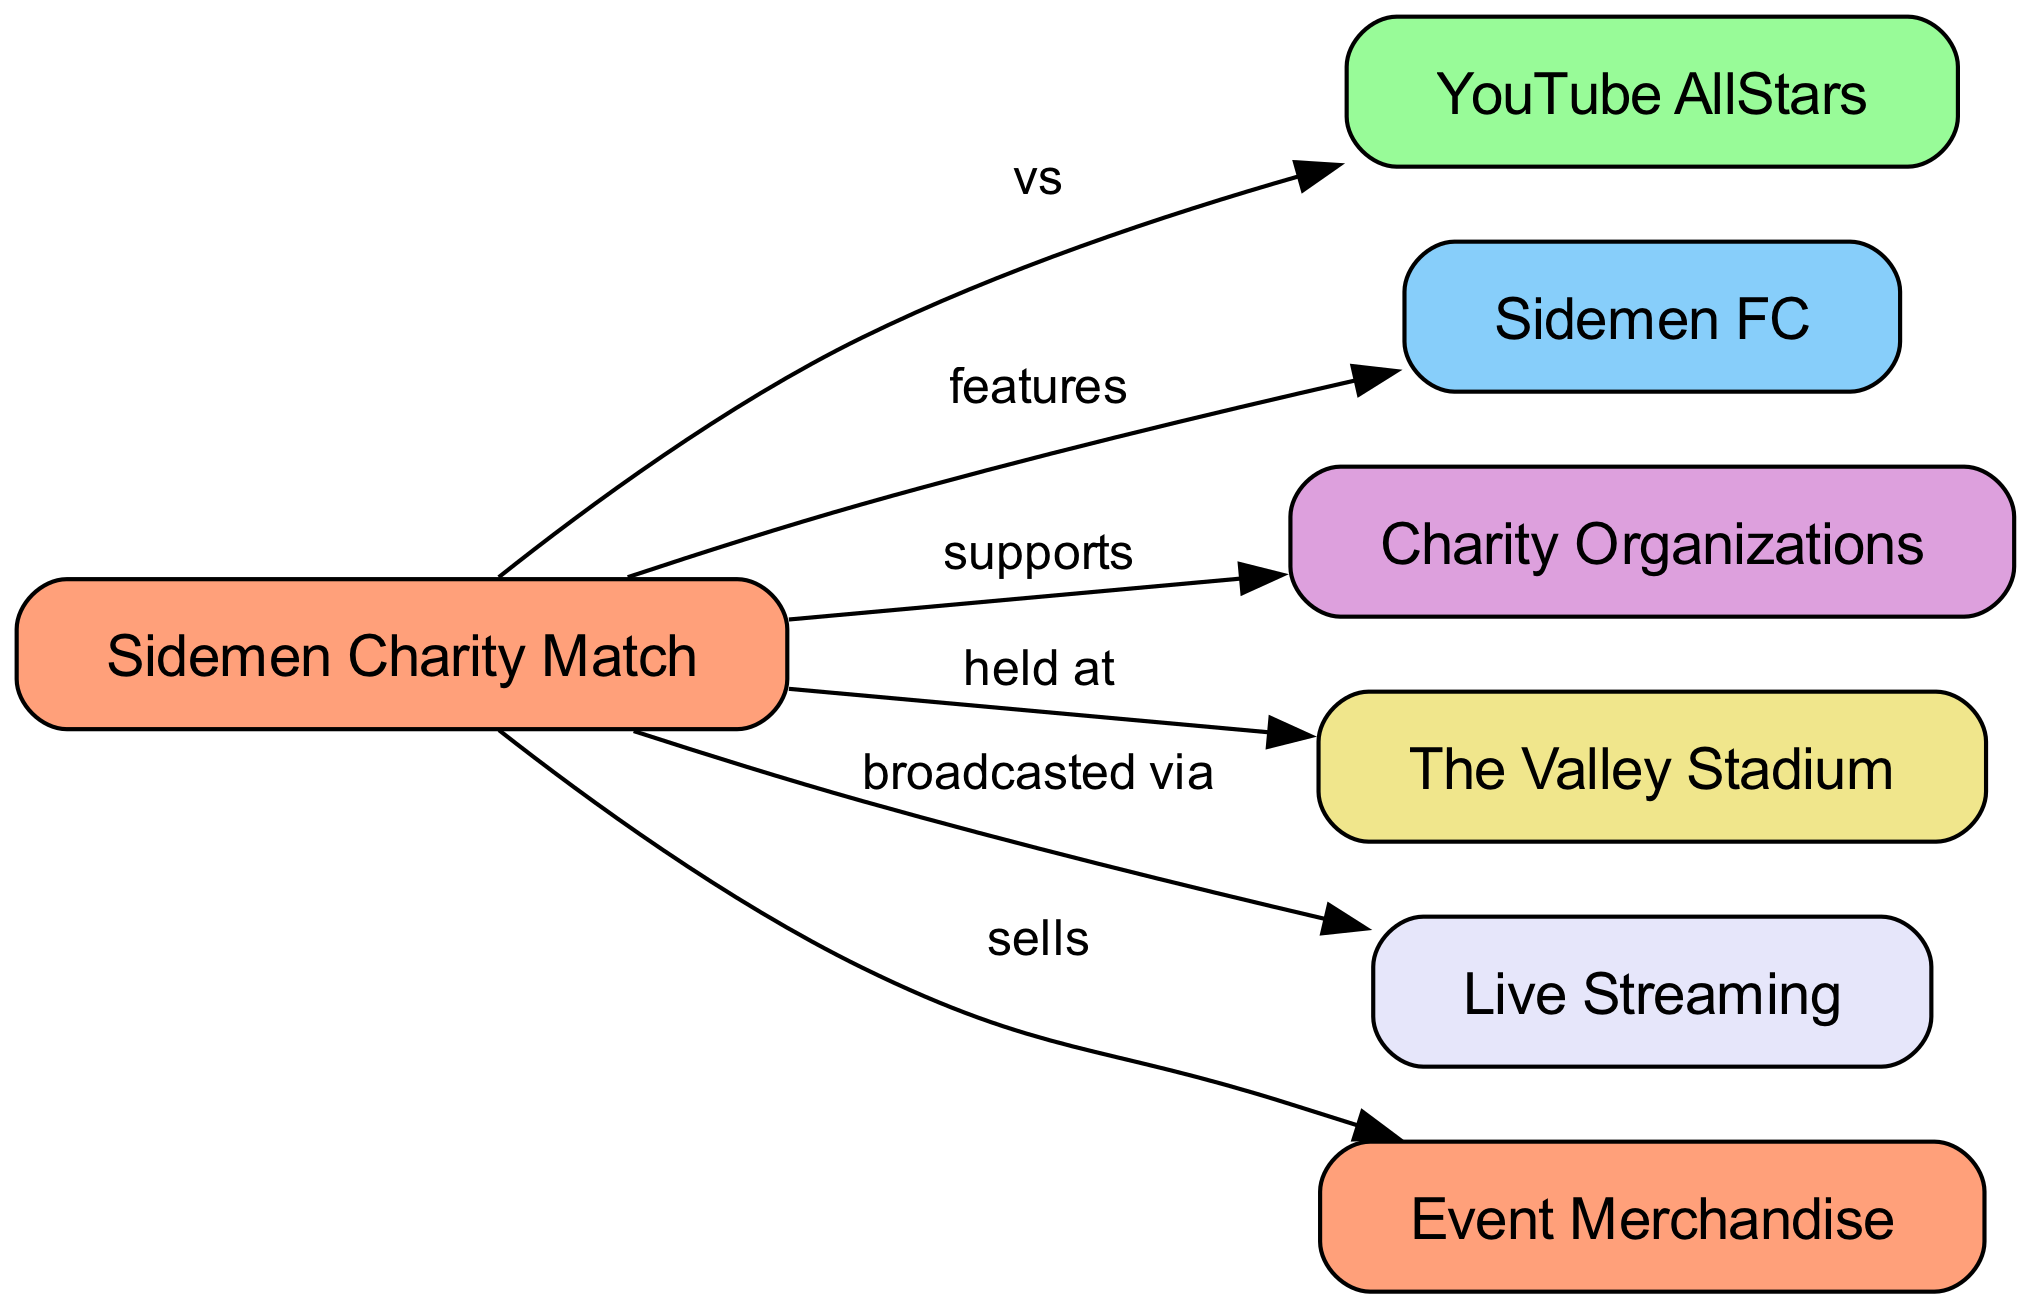What is the main event depicted in the diagram? The main event shown in the diagram is the "Sidemen Charity Match." This can be identified as it is the central node that connects to other nodes.
Answer: Sidemen Charity Match How many nodes are in the diagram? By counting all the nodes listed in the diagram, we can see that there are a total of 6 nodes. Each node represents a distinct component related to the charity match.
Answer: 6 What organization does the Sidemen Charity Match support? According to the edge that connects the "Sidemen Charity Match" node to the "Charity Organizations" node, it is clear that the match supports charity organizations.
Answer: Charity Organizations Where is the Sidemen Charity Match held? The diagram shows an edge from the "Sidemen Charity Match" to "The Valley Stadium," indicating that this is the venue for the match.
Answer: The Valley Stadium What type of match is the Sidemen Charity Match compared to another group? In the diagram, it states that the "Sidemen Charity Match" is held "vs" the "YouTube AllStars." This indicates it is a competitive match between these two entities.
Answer: YouTube AllStars What does the Sidemen Charity Match sell? The diagram directly indicates that the match sells "Event Merchandise," which is another aspect that adds to the fundraising efforts of the charity match.
Answer: Event Merchandise How is the Sidemen Charity Match broadcasted? The edge between "Sidemen Charity Match" and "Live Streaming" expresses that the event is broadcasted through live streaming, allowing viewers to watch online.
Answer: Live Streaming Which team features in the Sidemen Charity Match? The relationship described in the diagram indicates that "Sidemen FC" features in the match, making it a key participant in the event.
Answer: Sidemen FC How many edges connect to the Sidemen Charity Match? By counting the edges leading from "Sidemen Charity Match" to other nodes, we can determine there are 6 edges, each representing a relationship to various components.
Answer: 6 